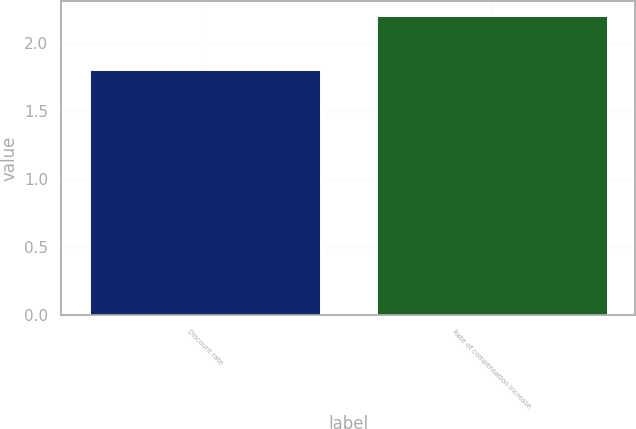Convert chart. <chart><loc_0><loc_0><loc_500><loc_500><bar_chart><fcel>Discount rate<fcel>Rate of compensation increase<nl><fcel>1.8<fcel>2.2<nl></chart> 